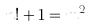<formula> <loc_0><loc_0><loc_500><loc_500>n ! + 1 = m ^ { 2 }</formula> 